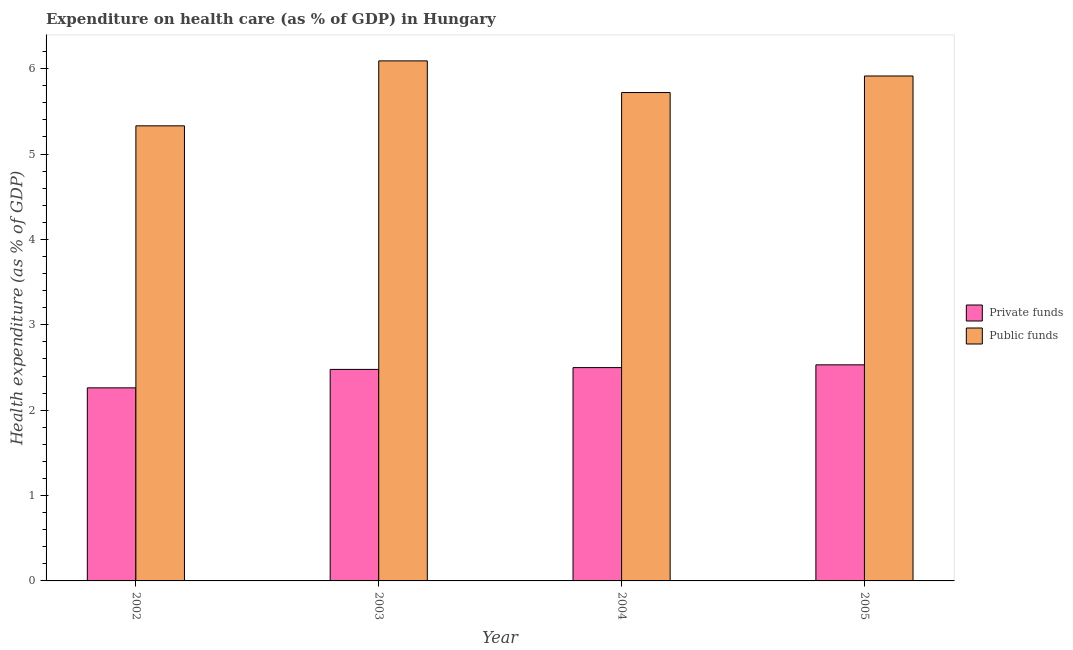Are the number of bars per tick equal to the number of legend labels?
Ensure brevity in your answer.  Yes. How many bars are there on the 3rd tick from the right?
Ensure brevity in your answer.  2. What is the label of the 1st group of bars from the left?
Offer a very short reply. 2002. In how many cases, is the number of bars for a given year not equal to the number of legend labels?
Provide a short and direct response. 0. What is the amount of private funds spent in healthcare in 2005?
Provide a succinct answer. 2.53. Across all years, what is the maximum amount of public funds spent in healthcare?
Offer a very short reply. 6.09. Across all years, what is the minimum amount of public funds spent in healthcare?
Offer a very short reply. 5.33. In which year was the amount of private funds spent in healthcare minimum?
Ensure brevity in your answer.  2002. What is the total amount of private funds spent in healthcare in the graph?
Make the answer very short. 9.77. What is the difference between the amount of public funds spent in healthcare in 2003 and that in 2005?
Keep it short and to the point. 0.18. What is the difference between the amount of private funds spent in healthcare in 2005 and the amount of public funds spent in healthcare in 2004?
Offer a terse response. 0.03. What is the average amount of public funds spent in healthcare per year?
Keep it short and to the point. 5.76. What is the ratio of the amount of private funds spent in healthcare in 2004 to that in 2005?
Provide a short and direct response. 0.99. Is the amount of private funds spent in healthcare in 2002 less than that in 2005?
Keep it short and to the point. Yes. Is the difference between the amount of private funds spent in healthcare in 2003 and 2004 greater than the difference between the amount of public funds spent in healthcare in 2003 and 2004?
Your response must be concise. No. What is the difference between the highest and the second highest amount of private funds spent in healthcare?
Ensure brevity in your answer.  0.03. What is the difference between the highest and the lowest amount of public funds spent in healthcare?
Provide a short and direct response. 0.76. In how many years, is the amount of public funds spent in healthcare greater than the average amount of public funds spent in healthcare taken over all years?
Offer a very short reply. 2. What does the 1st bar from the left in 2002 represents?
Give a very brief answer. Private funds. What does the 2nd bar from the right in 2002 represents?
Offer a very short reply. Private funds. How many bars are there?
Your response must be concise. 8. How many years are there in the graph?
Make the answer very short. 4. What is the difference between two consecutive major ticks on the Y-axis?
Give a very brief answer. 1. What is the title of the graph?
Ensure brevity in your answer.  Expenditure on health care (as % of GDP) in Hungary. What is the label or title of the X-axis?
Give a very brief answer. Year. What is the label or title of the Y-axis?
Offer a very short reply. Health expenditure (as % of GDP). What is the Health expenditure (as % of GDP) of Private funds in 2002?
Provide a succinct answer. 2.26. What is the Health expenditure (as % of GDP) in Public funds in 2002?
Your answer should be very brief. 5.33. What is the Health expenditure (as % of GDP) of Private funds in 2003?
Provide a succinct answer. 2.48. What is the Health expenditure (as % of GDP) in Public funds in 2003?
Provide a succinct answer. 6.09. What is the Health expenditure (as % of GDP) in Private funds in 2004?
Keep it short and to the point. 2.5. What is the Health expenditure (as % of GDP) of Public funds in 2004?
Give a very brief answer. 5.72. What is the Health expenditure (as % of GDP) of Private funds in 2005?
Your answer should be compact. 2.53. What is the Health expenditure (as % of GDP) in Public funds in 2005?
Your answer should be compact. 5.91. Across all years, what is the maximum Health expenditure (as % of GDP) of Private funds?
Ensure brevity in your answer.  2.53. Across all years, what is the maximum Health expenditure (as % of GDP) in Public funds?
Provide a succinct answer. 6.09. Across all years, what is the minimum Health expenditure (as % of GDP) in Private funds?
Your answer should be compact. 2.26. Across all years, what is the minimum Health expenditure (as % of GDP) of Public funds?
Provide a succinct answer. 5.33. What is the total Health expenditure (as % of GDP) in Private funds in the graph?
Your answer should be compact. 9.77. What is the total Health expenditure (as % of GDP) of Public funds in the graph?
Ensure brevity in your answer.  23.06. What is the difference between the Health expenditure (as % of GDP) in Private funds in 2002 and that in 2003?
Your answer should be very brief. -0.22. What is the difference between the Health expenditure (as % of GDP) of Public funds in 2002 and that in 2003?
Provide a succinct answer. -0.76. What is the difference between the Health expenditure (as % of GDP) in Private funds in 2002 and that in 2004?
Offer a terse response. -0.24. What is the difference between the Health expenditure (as % of GDP) of Public funds in 2002 and that in 2004?
Keep it short and to the point. -0.39. What is the difference between the Health expenditure (as % of GDP) in Private funds in 2002 and that in 2005?
Your answer should be compact. -0.27. What is the difference between the Health expenditure (as % of GDP) in Public funds in 2002 and that in 2005?
Give a very brief answer. -0.58. What is the difference between the Health expenditure (as % of GDP) of Private funds in 2003 and that in 2004?
Your answer should be compact. -0.02. What is the difference between the Health expenditure (as % of GDP) in Public funds in 2003 and that in 2004?
Offer a terse response. 0.37. What is the difference between the Health expenditure (as % of GDP) of Private funds in 2003 and that in 2005?
Ensure brevity in your answer.  -0.05. What is the difference between the Health expenditure (as % of GDP) in Public funds in 2003 and that in 2005?
Offer a terse response. 0.18. What is the difference between the Health expenditure (as % of GDP) in Private funds in 2004 and that in 2005?
Offer a very short reply. -0.03. What is the difference between the Health expenditure (as % of GDP) in Public funds in 2004 and that in 2005?
Your response must be concise. -0.19. What is the difference between the Health expenditure (as % of GDP) of Private funds in 2002 and the Health expenditure (as % of GDP) of Public funds in 2003?
Ensure brevity in your answer.  -3.83. What is the difference between the Health expenditure (as % of GDP) of Private funds in 2002 and the Health expenditure (as % of GDP) of Public funds in 2004?
Your answer should be very brief. -3.46. What is the difference between the Health expenditure (as % of GDP) of Private funds in 2002 and the Health expenditure (as % of GDP) of Public funds in 2005?
Keep it short and to the point. -3.65. What is the difference between the Health expenditure (as % of GDP) of Private funds in 2003 and the Health expenditure (as % of GDP) of Public funds in 2004?
Your answer should be compact. -3.24. What is the difference between the Health expenditure (as % of GDP) of Private funds in 2003 and the Health expenditure (as % of GDP) of Public funds in 2005?
Offer a terse response. -3.44. What is the difference between the Health expenditure (as % of GDP) in Private funds in 2004 and the Health expenditure (as % of GDP) in Public funds in 2005?
Give a very brief answer. -3.42. What is the average Health expenditure (as % of GDP) of Private funds per year?
Provide a succinct answer. 2.44. What is the average Health expenditure (as % of GDP) in Public funds per year?
Your response must be concise. 5.76. In the year 2002, what is the difference between the Health expenditure (as % of GDP) of Private funds and Health expenditure (as % of GDP) of Public funds?
Your answer should be compact. -3.07. In the year 2003, what is the difference between the Health expenditure (as % of GDP) of Private funds and Health expenditure (as % of GDP) of Public funds?
Offer a terse response. -3.61. In the year 2004, what is the difference between the Health expenditure (as % of GDP) in Private funds and Health expenditure (as % of GDP) in Public funds?
Provide a succinct answer. -3.22. In the year 2005, what is the difference between the Health expenditure (as % of GDP) in Private funds and Health expenditure (as % of GDP) in Public funds?
Ensure brevity in your answer.  -3.38. What is the ratio of the Health expenditure (as % of GDP) in Private funds in 2002 to that in 2003?
Provide a short and direct response. 0.91. What is the ratio of the Health expenditure (as % of GDP) in Public funds in 2002 to that in 2003?
Make the answer very short. 0.88. What is the ratio of the Health expenditure (as % of GDP) of Private funds in 2002 to that in 2004?
Offer a very short reply. 0.91. What is the ratio of the Health expenditure (as % of GDP) of Public funds in 2002 to that in 2004?
Your answer should be very brief. 0.93. What is the ratio of the Health expenditure (as % of GDP) of Private funds in 2002 to that in 2005?
Give a very brief answer. 0.89. What is the ratio of the Health expenditure (as % of GDP) in Public funds in 2002 to that in 2005?
Provide a short and direct response. 0.9. What is the ratio of the Health expenditure (as % of GDP) in Public funds in 2003 to that in 2004?
Keep it short and to the point. 1.06. What is the ratio of the Health expenditure (as % of GDP) of Private funds in 2003 to that in 2005?
Make the answer very short. 0.98. What is the ratio of the Health expenditure (as % of GDP) of Public funds in 2003 to that in 2005?
Ensure brevity in your answer.  1.03. What is the ratio of the Health expenditure (as % of GDP) in Private funds in 2004 to that in 2005?
Make the answer very short. 0.99. What is the ratio of the Health expenditure (as % of GDP) of Public funds in 2004 to that in 2005?
Keep it short and to the point. 0.97. What is the difference between the highest and the second highest Health expenditure (as % of GDP) in Private funds?
Offer a very short reply. 0.03. What is the difference between the highest and the second highest Health expenditure (as % of GDP) of Public funds?
Provide a succinct answer. 0.18. What is the difference between the highest and the lowest Health expenditure (as % of GDP) of Private funds?
Make the answer very short. 0.27. What is the difference between the highest and the lowest Health expenditure (as % of GDP) of Public funds?
Offer a terse response. 0.76. 